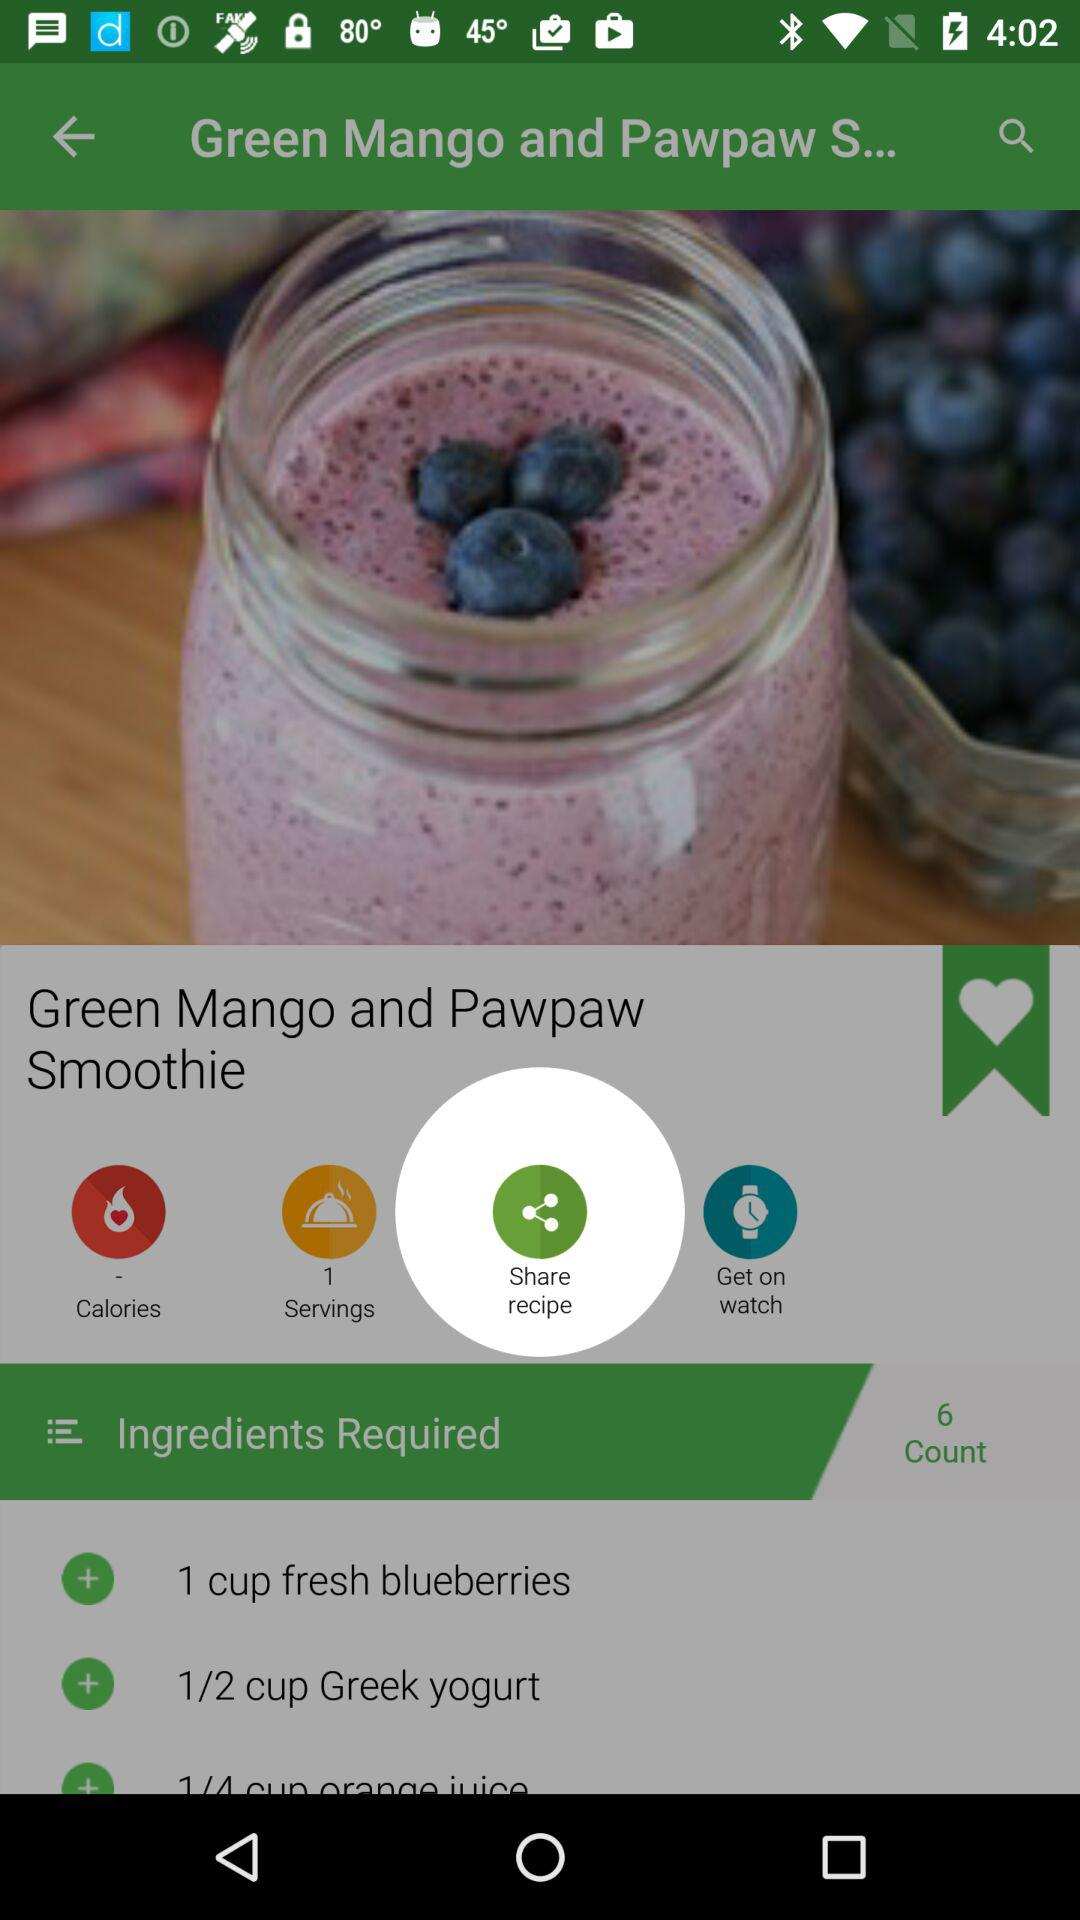How many ingredients are in the recipe?
Answer the question using a single word or phrase. 3 